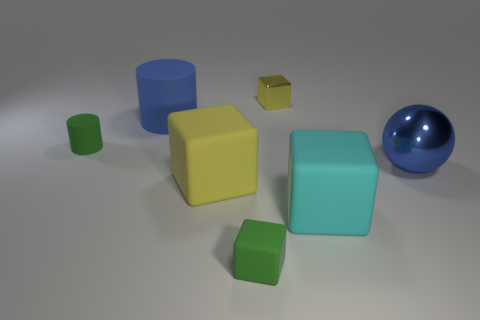Add 2 metallic blocks. How many objects exist? 9 Subtract all cubes. How many objects are left? 3 Subtract all big gray metal things. Subtract all blue matte things. How many objects are left? 6 Add 4 big yellow things. How many big yellow things are left? 5 Add 5 big red balls. How many big red balls exist? 5 Subtract 0 gray balls. How many objects are left? 7 